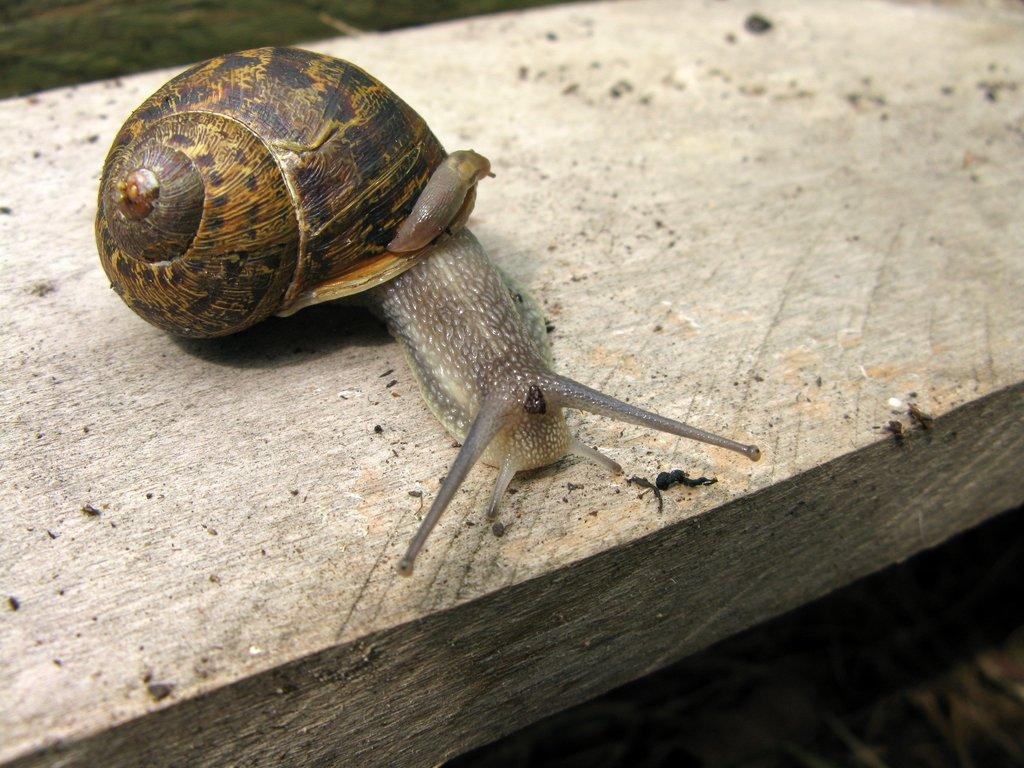Please provide a concise description of this image. In this image we can see snail on a wooden object. 